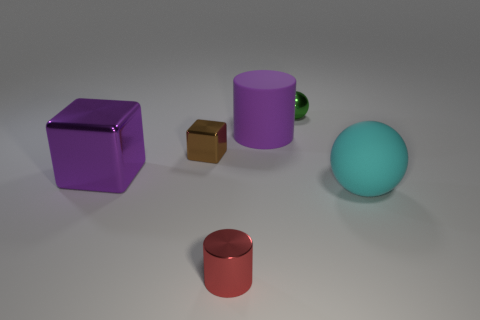Add 3 big cyan matte spheres. How many objects exist? 9 Subtract 1 balls. How many balls are left? 1 Subtract all cylinders. How many objects are left? 4 Add 4 tiny green balls. How many tiny green balls are left? 5 Add 4 brown metal blocks. How many brown metal blocks exist? 5 Subtract 0 red spheres. How many objects are left? 6 Subtract all purple cylinders. Subtract all cyan cubes. How many cylinders are left? 1 Subtract all small red cylinders. Subtract all shiny things. How many objects are left? 1 